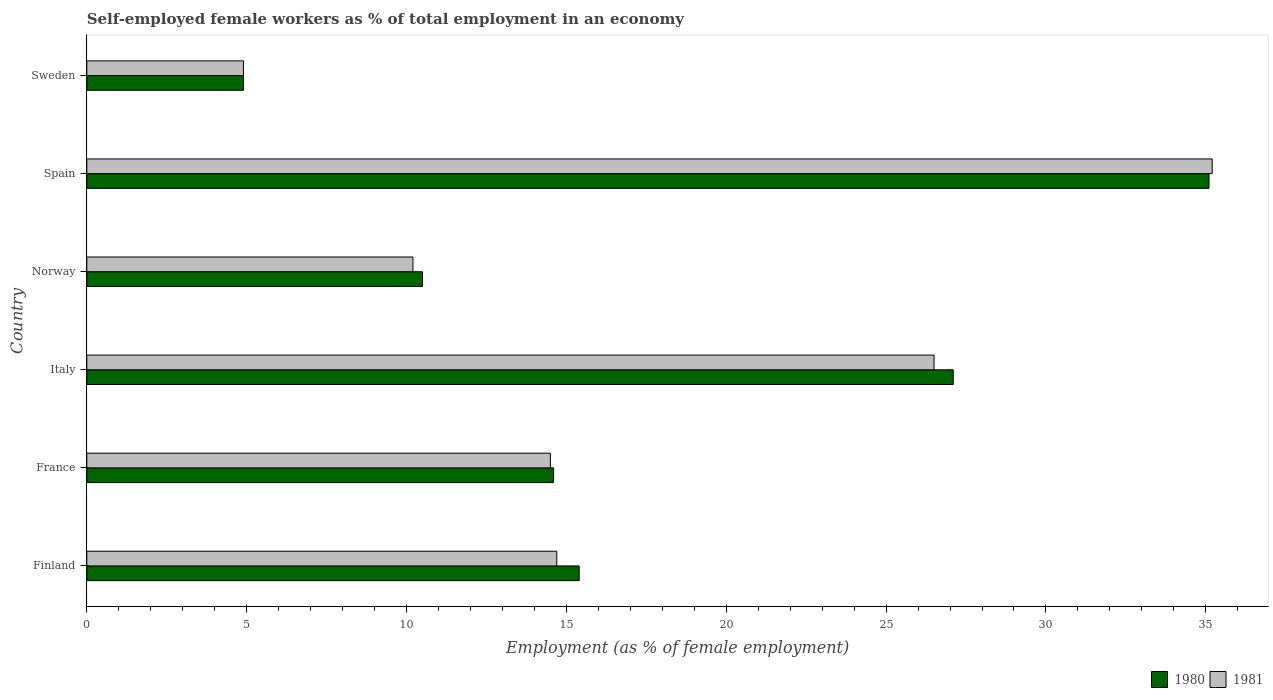How many different coloured bars are there?
Provide a short and direct response. 2. How many groups of bars are there?
Your answer should be very brief. 6. Are the number of bars on each tick of the Y-axis equal?
Offer a terse response. Yes. How many bars are there on the 6th tick from the top?
Keep it short and to the point. 2. What is the percentage of self-employed female workers in 1980 in Finland?
Your answer should be compact. 15.4. Across all countries, what is the maximum percentage of self-employed female workers in 1980?
Provide a short and direct response. 35.1. Across all countries, what is the minimum percentage of self-employed female workers in 1980?
Offer a terse response. 4.9. In which country was the percentage of self-employed female workers in 1981 maximum?
Offer a very short reply. Spain. In which country was the percentage of self-employed female workers in 1981 minimum?
Your response must be concise. Sweden. What is the total percentage of self-employed female workers in 1981 in the graph?
Provide a short and direct response. 106. What is the difference between the percentage of self-employed female workers in 1981 in France and that in Sweden?
Your answer should be very brief. 9.6. What is the difference between the percentage of self-employed female workers in 1980 in Finland and the percentage of self-employed female workers in 1981 in France?
Give a very brief answer. 0.9. What is the average percentage of self-employed female workers in 1981 per country?
Ensure brevity in your answer.  17.67. What is the difference between the percentage of self-employed female workers in 1981 and percentage of self-employed female workers in 1980 in Italy?
Your answer should be compact. -0.6. In how many countries, is the percentage of self-employed female workers in 1980 greater than 5 %?
Ensure brevity in your answer.  5. What is the ratio of the percentage of self-employed female workers in 1981 in France to that in Italy?
Make the answer very short. 0.55. Is the percentage of self-employed female workers in 1980 in France less than that in Italy?
Offer a terse response. Yes. Is the difference between the percentage of self-employed female workers in 1981 in Italy and Norway greater than the difference between the percentage of self-employed female workers in 1980 in Italy and Norway?
Keep it short and to the point. No. What is the difference between the highest and the second highest percentage of self-employed female workers in 1981?
Make the answer very short. 8.7. What is the difference between the highest and the lowest percentage of self-employed female workers in 1980?
Your answer should be compact. 30.2. Is the sum of the percentage of self-employed female workers in 1980 in Finland and Spain greater than the maximum percentage of self-employed female workers in 1981 across all countries?
Give a very brief answer. Yes. What does the 2nd bar from the top in Spain represents?
Offer a terse response. 1980. Are all the bars in the graph horizontal?
Your answer should be very brief. Yes. What is the difference between two consecutive major ticks on the X-axis?
Provide a succinct answer. 5. Does the graph contain any zero values?
Your answer should be compact. No. Does the graph contain grids?
Your response must be concise. No. What is the title of the graph?
Keep it short and to the point. Self-employed female workers as % of total employment in an economy. What is the label or title of the X-axis?
Provide a short and direct response. Employment (as % of female employment). What is the Employment (as % of female employment) of 1980 in Finland?
Ensure brevity in your answer.  15.4. What is the Employment (as % of female employment) in 1981 in Finland?
Ensure brevity in your answer.  14.7. What is the Employment (as % of female employment) in 1980 in France?
Give a very brief answer. 14.6. What is the Employment (as % of female employment) in 1981 in France?
Your answer should be very brief. 14.5. What is the Employment (as % of female employment) of 1980 in Italy?
Make the answer very short. 27.1. What is the Employment (as % of female employment) in 1981 in Italy?
Your answer should be very brief. 26.5. What is the Employment (as % of female employment) in 1980 in Norway?
Make the answer very short. 10.5. What is the Employment (as % of female employment) of 1981 in Norway?
Give a very brief answer. 10.2. What is the Employment (as % of female employment) in 1980 in Spain?
Make the answer very short. 35.1. What is the Employment (as % of female employment) in 1981 in Spain?
Keep it short and to the point. 35.2. What is the Employment (as % of female employment) of 1980 in Sweden?
Offer a very short reply. 4.9. What is the Employment (as % of female employment) in 1981 in Sweden?
Provide a succinct answer. 4.9. Across all countries, what is the maximum Employment (as % of female employment) in 1980?
Offer a terse response. 35.1. Across all countries, what is the maximum Employment (as % of female employment) of 1981?
Offer a very short reply. 35.2. Across all countries, what is the minimum Employment (as % of female employment) of 1980?
Offer a very short reply. 4.9. Across all countries, what is the minimum Employment (as % of female employment) of 1981?
Keep it short and to the point. 4.9. What is the total Employment (as % of female employment) of 1980 in the graph?
Provide a short and direct response. 107.6. What is the total Employment (as % of female employment) in 1981 in the graph?
Ensure brevity in your answer.  106. What is the difference between the Employment (as % of female employment) in 1980 in Finland and that in France?
Your answer should be compact. 0.8. What is the difference between the Employment (as % of female employment) of 1981 in Finland and that in France?
Ensure brevity in your answer.  0.2. What is the difference between the Employment (as % of female employment) of 1980 in Finland and that in Italy?
Offer a terse response. -11.7. What is the difference between the Employment (as % of female employment) in 1980 in Finland and that in Spain?
Ensure brevity in your answer.  -19.7. What is the difference between the Employment (as % of female employment) in 1981 in Finland and that in Spain?
Keep it short and to the point. -20.5. What is the difference between the Employment (as % of female employment) of 1980 in Finland and that in Sweden?
Offer a very short reply. 10.5. What is the difference between the Employment (as % of female employment) of 1980 in France and that in Italy?
Offer a very short reply. -12.5. What is the difference between the Employment (as % of female employment) in 1981 in France and that in Italy?
Keep it short and to the point. -12. What is the difference between the Employment (as % of female employment) in 1980 in France and that in Spain?
Give a very brief answer. -20.5. What is the difference between the Employment (as % of female employment) of 1981 in France and that in Spain?
Give a very brief answer. -20.7. What is the difference between the Employment (as % of female employment) of 1981 in Italy and that in Norway?
Provide a short and direct response. 16.3. What is the difference between the Employment (as % of female employment) in 1980 in Italy and that in Spain?
Your answer should be very brief. -8. What is the difference between the Employment (as % of female employment) of 1981 in Italy and that in Spain?
Provide a succinct answer. -8.7. What is the difference between the Employment (as % of female employment) in 1981 in Italy and that in Sweden?
Ensure brevity in your answer.  21.6. What is the difference between the Employment (as % of female employment) in 1980 in Norway and that in Spain?
Make the answer very short. -24.6. What is the difference between the Employment (as % of female employment) in 1981 in Norway and that in Spain?
Offer a terse response. -25. What is the difference between the Employment (as % of female employment) of 1980 in Norway and that in Sweden?
Offer a terse response. 5.6. What is the difference between the Employment (as % of female employment) of 1981 in Norway and that in Sweden?
Ensure brevity in your answer.  5.3. What is the difference between the Employment (as % of female employment) in 1980 in Spain and that in Sweden?
Offer a very short reply. 30.2. What is the difference between the Employment (as % of female employment) of 1981 in Spain and that in Sweden?
Provide a succinct answer. 30.3. What is the difference between the Employment (as % of female employment) in 1980 in Finland and the Employment (as % of female employment) in 1981 in France?
Give a very brief answer. 0.9. What is the difference between the Employment (as % of female employment) of 1980 in Finland and the Employment (as % of female employment) of 1981 in Italy?
Your response must be concise. -11.1. What is the difference between the Employment (as % of female employment) of 1980 in Finland and the Employment (as % of female employment) of 1981 in Norway?
Ensure brevity in your answer.  5.2. What is the difference between the Employment (as % of female employment) of 1980 in Finland and the Employment (as % of female employment) of 1981 in Spain?
Ensure brevity in your answer.  -19.8. What is the difference between the Employment (as % of female employment) of 1980 in Finland and the Employment (as % of female employment) of 1981 in Sweden?
Your answer should be compact. 10.5. What is the difference between the Employment (as % of female employment) in 1980 in France and the Employment (as % of female employment) in 1981 in Italy?
Provide a succinct answer. -11.9. What is the difference between the Employment (as % of female employment) in 1980 in France and the Employment (as % of female employment) in 1981 in Spain?
Offer a very short reply. -20.6. What is the difference between the Employment (as % of female employment) of 1980 in France and the Employment (as % of female employment) of 1981 in Sweden?
Provide a succinct answer. 9.7. What is the difference between the Employment (as % of female employment) of 1980 in Italy and the Employment (as % of female employment) of 1981 in Sweden?
Offer a very short reply. 22.2. What is the difference between the Employment (as % of female employment) in 1980 in Norway and the Employment (as % of female employment) in 1981 in Spain?
Ensure brevity in your answer.  -24.7. What is the difference between the Employment (as % of female employment) in 1980 in Norway and the Employment (as % of female employment) in 1981 in Sweden?
Keep it short and to the point. 5.6. What is the difference between the Employment (as % of female employment) of 1980 in Spain and the Employment (as % of female employment) of 1981 in Sweden?
Provide a short and direct response. 30.2. What is the average Employment (as % of female employment) of 1980 per country?
Offer a terse response. 17.93. What is the average Employment (as % of female employment) of 1981 per country?
Your response must be concise. 17.67. What is the difference between the Employment (as % of female employment) of 1980 and Employment (as % of female employment) of 1981 in France?
Keep it short and to the point. 0.1. What is the difference between the Employment (as % of female employment) in 1980 and Employment (as % of female employment) in 1981 in Italy?
Your answer should be compact. 0.6. What is the difference between the Employment (as % of female employment) in 1980 and Employment (as % of female employment) in 1981 in Spain?
Give a very brief answer. -0.1. What is the ratio of the Employment (as % of female employment) in 1980 in Finland to that in France?
Your response must be concise. 1.05. What is the ratio of the Employment (as % of female employment) in 1981 in Finland to that in France?
Your answer should be compact. 1.01. What is the ratio of the Employment (as % of female employment) of 1980 in Finland to that in Italy?
Make the answer very short. 0.57. What is the ratio of the Employment (as % of female employment) in 1981 in Finland to that in Italy?
Ensure brevity in your answer.  0.55. What is the ratio of the Employment (as % of female employment) in 1980 in Finland to that in Norway?
Offer a terse response. 1.47. What is the ratio of the Employment (as % of female employment) in 1981 in Finland to that in Norway?
Your response must be concise. 1.44. What is the ratio of the Employment (as % of female employment) in 1980 in Finland to that in Spain?
Offer a very short reply. 0.44. What is the ratio of the Employment (as % of female employment) in 1981 in Finland to that in Spain?
Make the answer very short. 0.42. What is the ratio of the Employment (as % of female employment) in 1980 in Finland to that in Sweden?
Provide a short and direct response. 3.14. What is the ratio of the Employment (as % of female employment) in 1981 in Finland to that in Sweden?
Your response must be concise. 3. What is the ratio of the Employment (as % of female employment) of 1980 in France to that in Italy?
Make the answer very short. 0.54. What is the ratio of the Employment (as % of female employment) of 1981 in France to that in Italy?
Offer a terse response. 0.55. What is the ratio of the Employment (as % of female employment) in 1980 in France to that in Norway?
Provide a succinct answer. 1.39. What is the ratio of the Employment (as % of female employment) in 1981 in France to that in Norway?
Keep it short and to the point. 1.42. What is the ratio of the Employment (as % of female employment) in 1980 in France to that in Spain?
Give a very brief answer. 0.42. What is the ratio of the Employment (as % of female employment) of 1981 in France to that in Spain?
Your answer should be very brief. 0.41. What is the ratio of the Employment (as % of female employment) in 1980 in France to that in Sweden?
Your answer should be very brief. 2.98. What is the ratio of the Employment (as % of female employment) in 1981 in France to that in Sweden?
Provide a succinct answer. 2.96. What is the ratio of the Employment (as % of female employment) of 1980 in Italy to that in Norway?
Ensure brevity in your answer.  2.58. What is the ratio of the Employment (as % of female employment) in 1981 in Italy to that in Norway?
Your response must be concise. 2.6. What is the ratio of the Employment (as % of female employment) of 1980 in Italy to that in Spain?
Make the answer very short. 0.77. What is the ratio of the Employment (as % of female employment) in 1981 in Italy to that in Spain?
Offer a very short reply. 0.75. What is the ratio of the Employment (as % of female employment) of 1980 in Italy to that in Sweden?
Ensure brevity in your answer.  5.53. What is the ratio of the Employment (as % of female employment) of 1981 in Italy to that in Sweden?
Keep it short and to the point. 5.41. What is the ratio of the Employment (as % of female employment) in 1980 in Norway to that in Spain?
Offer a very short reply. 0.3. What is the ratio of the Employment (as % of female employment) in 1981 in Norway to that in Spain?
Your response must be concise. 0.29. What is the ratio of the Employment (as % of female employment) in 1980 in Norway to that in Sweden?
Offer a very short reply. 2.14. What is the ratio of the Employment (as % of female employment) in 1981 in Norway to that in Sweden?
Provide a succinct answer. 2.08. What is the ratio of the Employment (as % of female employment) of 1980 in Spain to that in Sweden?
Your answer should be very brief. 7.16. What is the ratio of the Employment (as % of female employment) in 1981 in Spain to that in Sweden?
Offer a terse response. 7.18. What is the difference between the highest and the second highest Employment (as % of female employment) of 1980?
Offer a terse response. 8. What is the difference between the highest and the lowest Employment (as % of female employment) in 1980?
Make the answer very short. 30.2. What is the difference between the highest and the lowest Employment (as % of female employment) of 1981?
Keep it short and to the point. 30.3. 